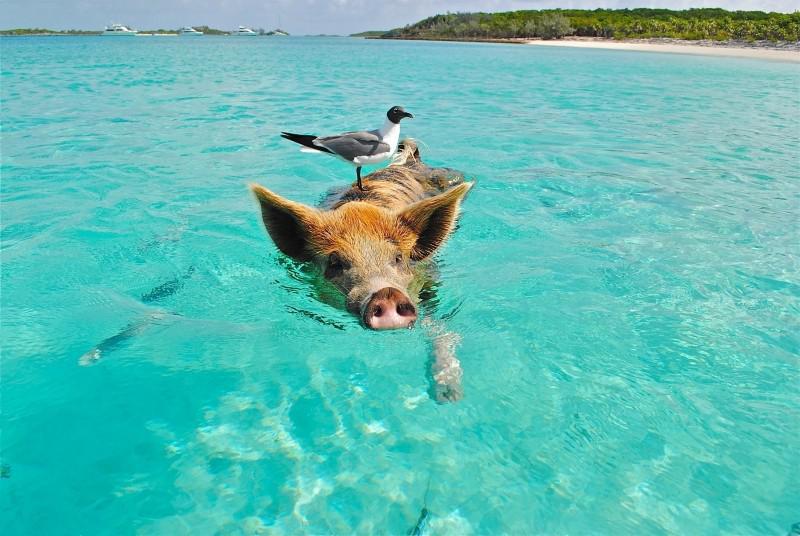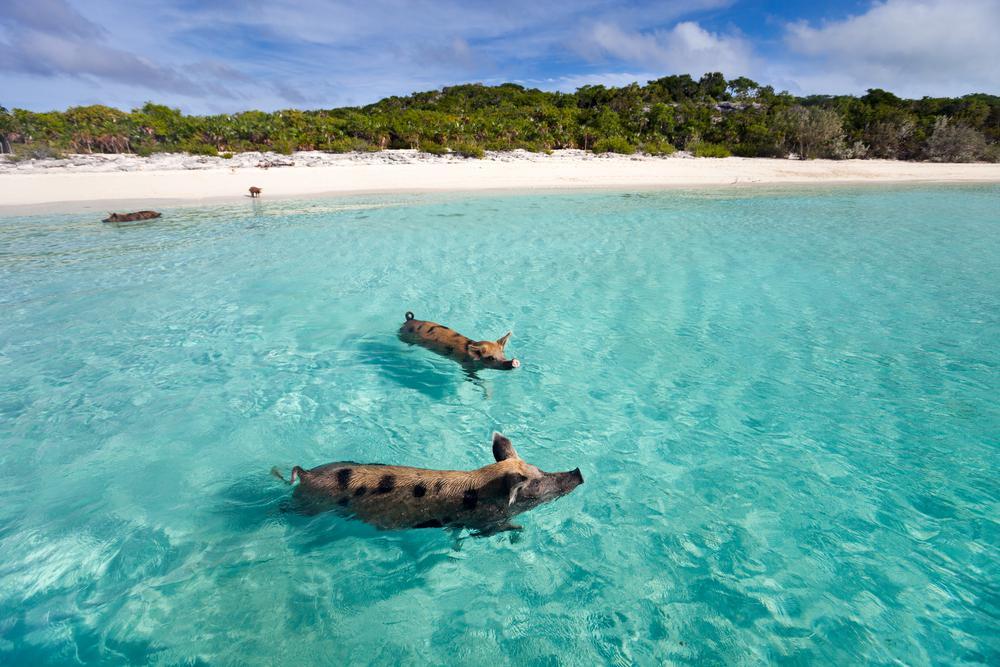The first image is the image on the left, the second image is the image on the right. Evaluate the accuracy of this statement regarding the images: "Each image shows two pigs swimming in a body of water, and in at least one image, the pigs' snouts face opposite directions.". Is it true? Answer yes or no. No. 